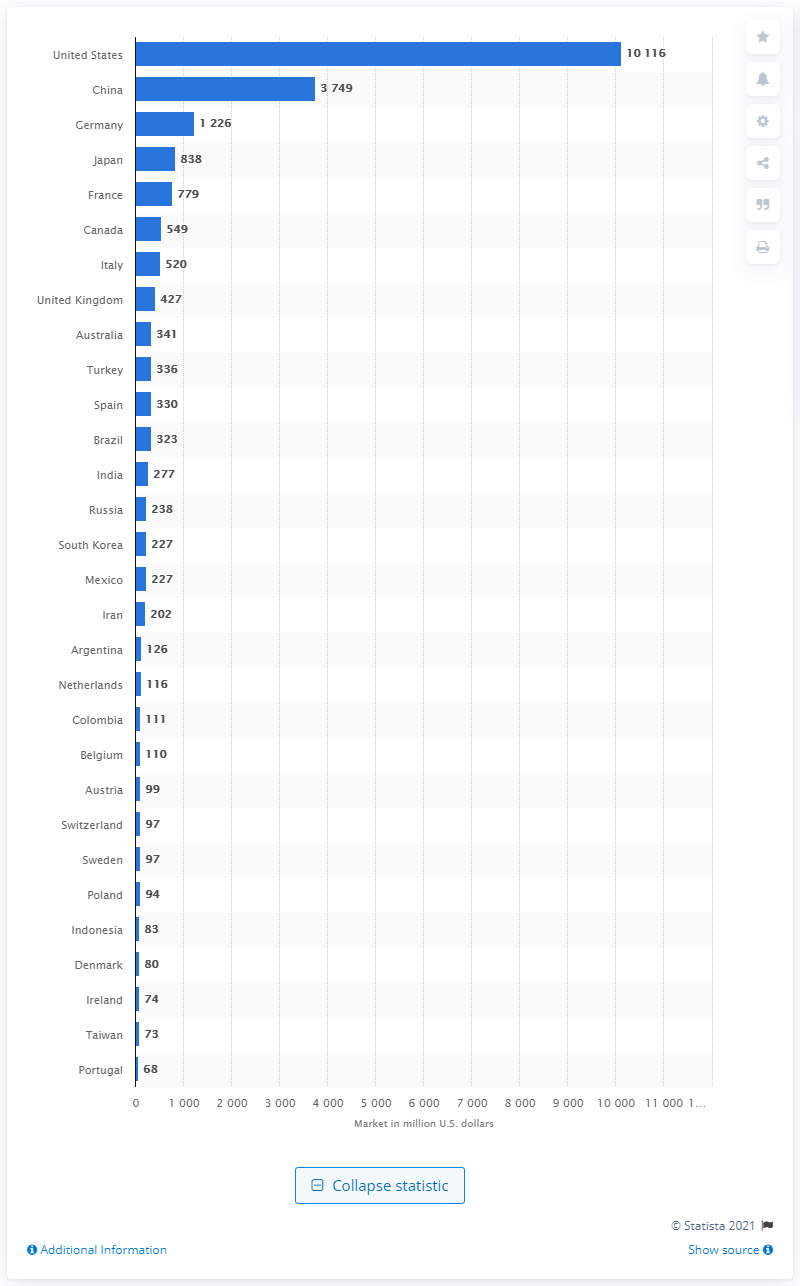Draw attention to some important aspects in this diagram. In 2017, the value of the plasma market in the U.S. was 10,116. In 2017, the value of the Chinese plasma market was approximately 3,749. 